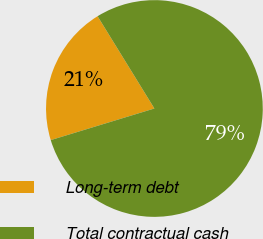Convert chart to OTSL. <chart><loc_0><loc_0><loc_500><loc_500><pie_chart><fcel>Long-term debt<fcel>Total contractual cash<nl><fcel>20.93%<fcel>79.07%<nl></chart> 